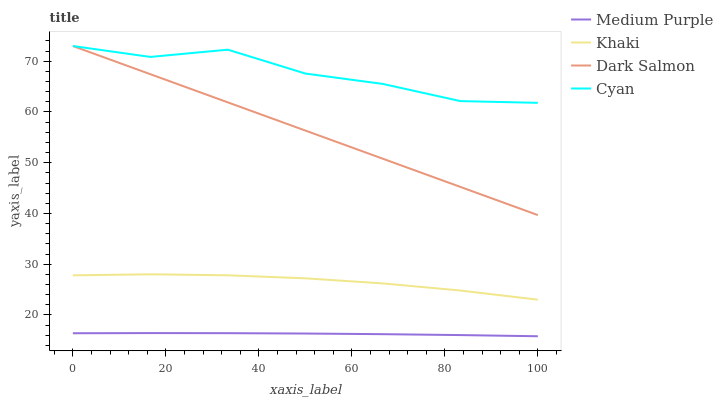Does Medium Purple have the minimum area under the curve?
Answer yes or no. Yes. Does Cyan have the maximum area under the curve?
Answer yes or no. Yes. Does Khaki have the minimum area under the curve?
Answer yes or no. No. Does Khaki have the maximum area under the curve?
Answer yes or no. No. Is Dark Salmon the smoothest?
Answer yes or no. Yes. Is Cyan the roughest?
Answer yes or no. Yes. Is Khaki the smoothest?
Answer yes or no. No. Is Khaki the roughest?
Answer yes or no. No. Does Khaki have the lowest value?
Answer yes or no. No. Does Dark Salmon have the highest value?
Answer yes or no. Yes. Does Khaki have the highest value?
Answer yes or no. No. Is Khaki less than Dark Salmon?
Answer yes or no. Yes. Is Khaki greater than Medium Purple?
Answer yes or no. Yes. Does Cyan intersect Dark Salmon?
Answer yes or no. Yes. Is Cyan less than Dark Salmon?
Answer yes or no. No. Is Cyan greater than Dark Salmon?
Answer yes or no. No. Does Khaki intersect Dark Salmon?
Answer yes or no. No. 